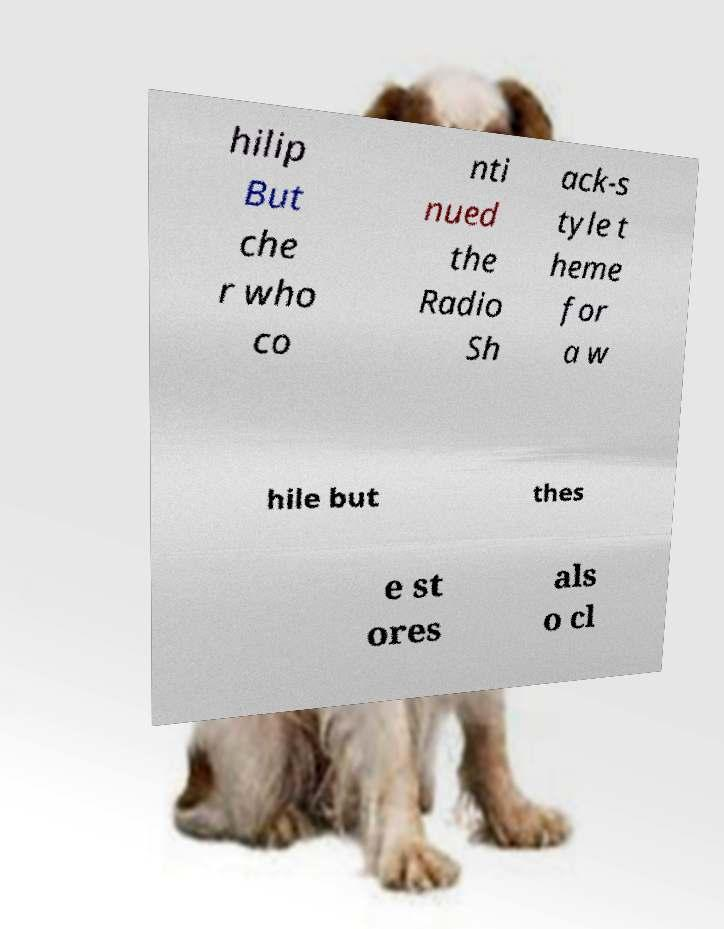Could you extract and type out the text from this image? hilip But che r who co nti nued the Radio Sh ack-s tyle t heme for a w hile but thes e st ores als o cl 